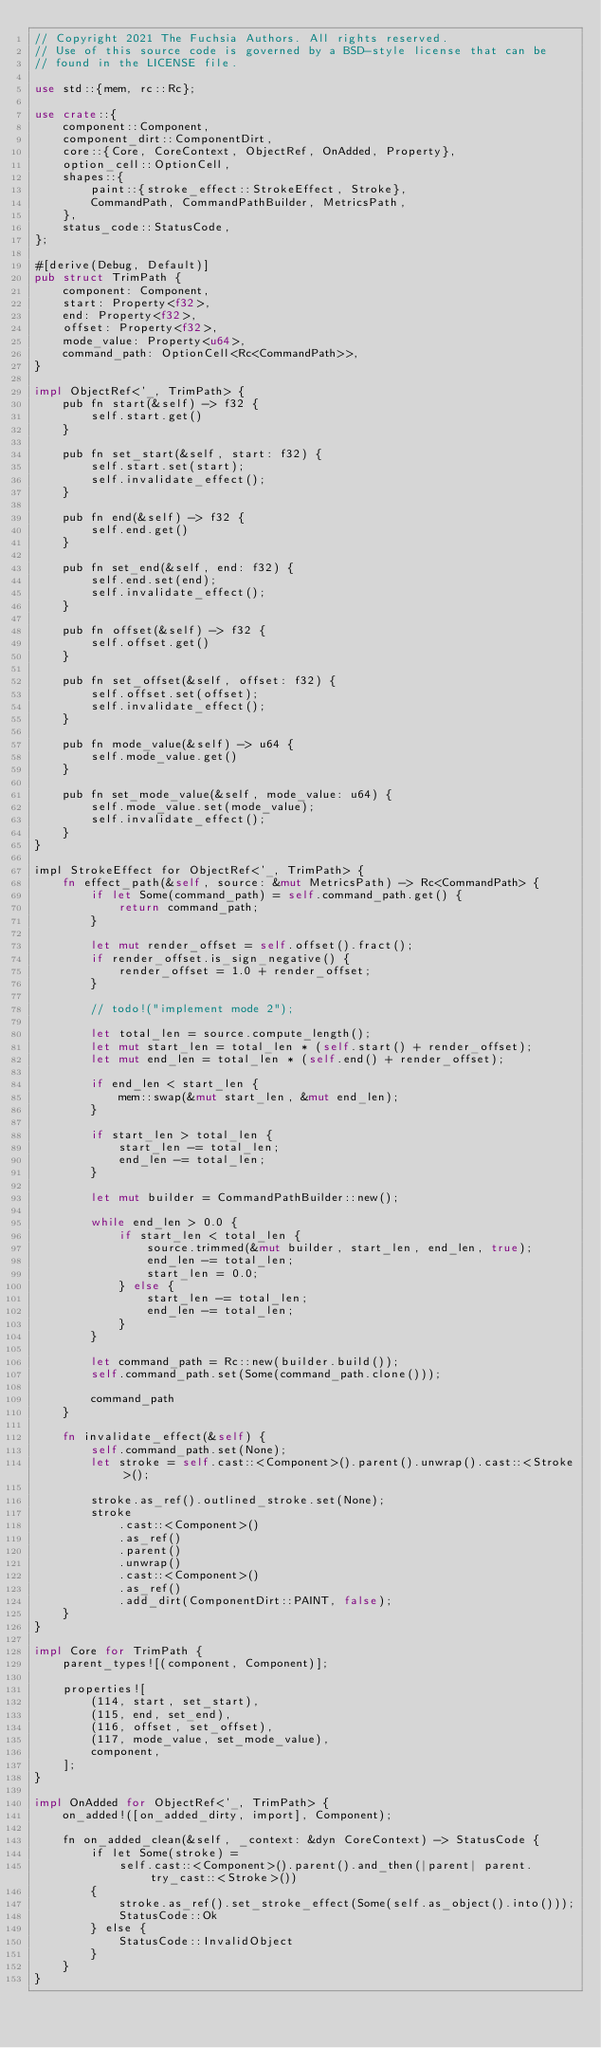Convert code to text. <code><loc_0><loc_0><loc_500><loc_500><_Rust_>// Copyright 2021 The Fuchsia Authors. All rights reserved.
// Use of this source code is governed by a BSD-style license that can be
// found in the LICENSE file.

use std::{mem, rc::Rc};

use crate::{
    component::Component,
    component_dirt::ComponentDirt,
    core::{Core, CoreContext, ObjectRef, OnAdded, Property},
    option_cell::OptionCell,
    shapes::{
        paint::{stroke_effect::StrokeEffect, Stroke},
        CommandPath, CommandPathBuilder, MetricsPath,
    },
    status_code::StatusCode,
};

#[derive(Debug, Default)]
pub struct TrimPath {
    component: Component,
    start: Property<f32>,
    end: Property<f32>,
    offset: Property<f32>,
    mode_value: Property<u64>,
    command_path: OptionCell<Rc<CommandPath>>,
}

impl ObjectRef<'_, TrimPath> {
    pub fn start(&self) -> f32 {
        self.start.get()
    }

    pub fn set_start(&self, start: f32) {
        self.start.set(start);
        self.invalidate_effect();
    }

    pub fn end(&self) -> f32 {
        self.end.get()
    }

    pub fn set_end(&self, end: f32) {
        self.end.set(end);
        self.invalidate_effect();
    }

    pub fn offset(&self) -> f32 {
        self.offset.get()
    }

    pub fn set_offset(&self, offset: f32) {
        self.offset.set(offset);
        self.invalidate_effect();
    }

    pub fn mode_value(&self) -> u64 {
        self.mode_value.get()
    }

    pub fn set_mode_value(&self, mode_value: u64) {
        self.mode_value.set(mode_value);
        self.invalidate_effect();
    }
}

impl StrokeEffect for ObjectRef<'_, TrimPath> {
    fn effect_path(&self, source: &mut MetricsPath) -> Rc<CommandPath> {
        if let Some(command_path) = self.command_path.get() {
            return command_path;
        }

        let mut render_offset = self.offset().fract();
        if render_offset.is_sign_negative() {
            render_offset = 1.0 + render_offset;
        }

        // todo!("implement mode 2");

        let total_len = source.compute_length();
        let mut start_len = total_len * (self.start() + render_offset);
        let mut end_len = total_len * (self.end() + render_offset);

        if end_len < start_len {
            mem::swap(&mut start_len, &mut end_len);
        }

        if start_len > total_len {
            start_len -= total_len;
            end_len -= total_len;
        }

        let mut builder = CommandPathBuilder::new();

        while end_len > 0.0 {
            if start_len < total_len {
                source.trimmed(&mut builder, start_len, end_len, true);
                end_len -= total_len;
                start_len = 0.0;
            } else {
                start_len -= total_len;
                end_len -= total_len;
            }
        }

        let command_path = Rc::new(builder.build());
        self.command_path.set(Some(command_path.clone()));

        command_path
    }

    fn invalidate_effect(&self) {
        self.command_path.set(None);
        let stroke = self.cast::<Component>().parent().unwrap().cast::<Stroke>();

        stroke.as_ref().outlined_stroke.set(None);
        stroke
            .cast::<Component>()
            .as_ref()
            .parent()
            .unwrap()
            .cast::<Component>()
            .as_ref()
            .add_dirt(ComponentDirt::PAINT, false);
    }
}

impl Core for TrimPath {
    parent_types![(component, Component)];

    properties![
        (114, start, set_start),
        (115, end, set_end),
        (116, offset, set_offset),
        (117, mode_value, set_mode_value),
        component,
    ];
}

impl OnAdded for ObjectRef<'_, TrimPath> {
    on_added!([on_added_dirty, import], Component);

    fn on_added_clean(&self, _context: &dyn CoreContext) -> StatusCode {
        if let Some(stroke) =
            self.cast::<Component>().parent().and_then(|parent| parent.try_cast::<Stroke>())
        {
            stroke.as_ref().set_stroke_effect(Some(self.as_object().into()));
            StatusCode::Ok
        } else {
            StatusCode::InvalidObject
        }
    }
}
</code> 